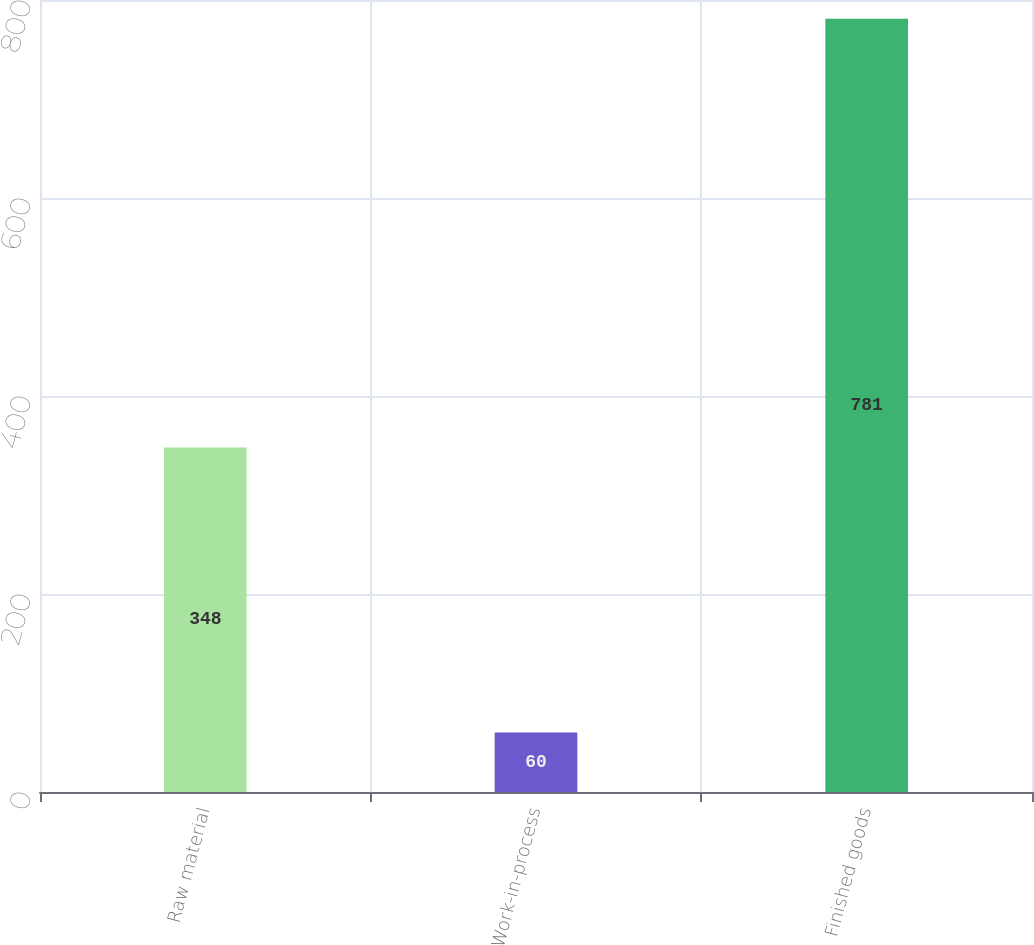<chart> <loc_0><loc_0><loc_500><loc_500><bar_chart><fcel>Raw material<fcel>Work-in-process<fcel>Finished goods<nl><fcel>348<fcel>60<fcel>781<nl></chart> 